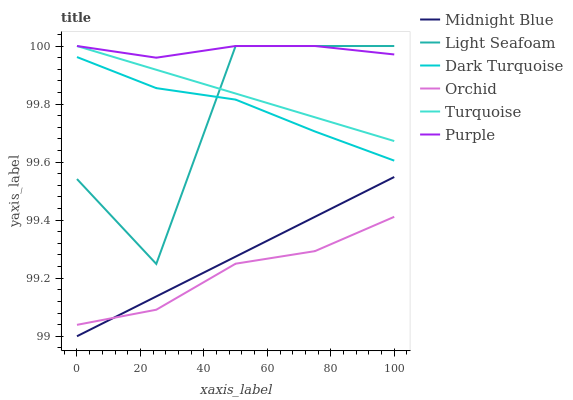Does Orchid have the minimum area under the curve?
Answer yes or no. Yes. Does Purple have the maximum area under the curve?
Answer yes or no. Yes. Does Midnight Blue have the minimum area under the curve?
Answer yes or no. No. Does Midnight Blue have the maximum area under the curve?
Answer yes or no. No. Is Midnight Blue the smoothest?
Answer yes or no. Yes. Is Light Seafoam the roughest?
Answer yes or no. Yes. Is Purple the smoothest?
Answer yes or no. No. Is Purple the roughest?
Answer yes or no. No. Does Midnight Blue have the lowest value?
Answer yes or no. Yes. Does Purple have the lowest value?
Answer yes or no. No. Does Light Seafoam have the highest value?
Answer yes or no. Yes. Does Midnight Blue have the highest value?
Answer yes or no. No. Is Orchid less than Dark Turquoise?
Answer yes or no. Yes. Is Light Seafoam greater than Orchid?
Answer yes or no. Yes. Does Turquoise intersect Light Seafoam?
Answer yes or no. Yes. Is Turquoise less than Light Seafoam?
Answer yes or no. No. Is Turquoise greater than Light Seafoam?
Answer yes or no. No. Does Orchid intersect Dark Turquoise?
Answer yes or no. No. 